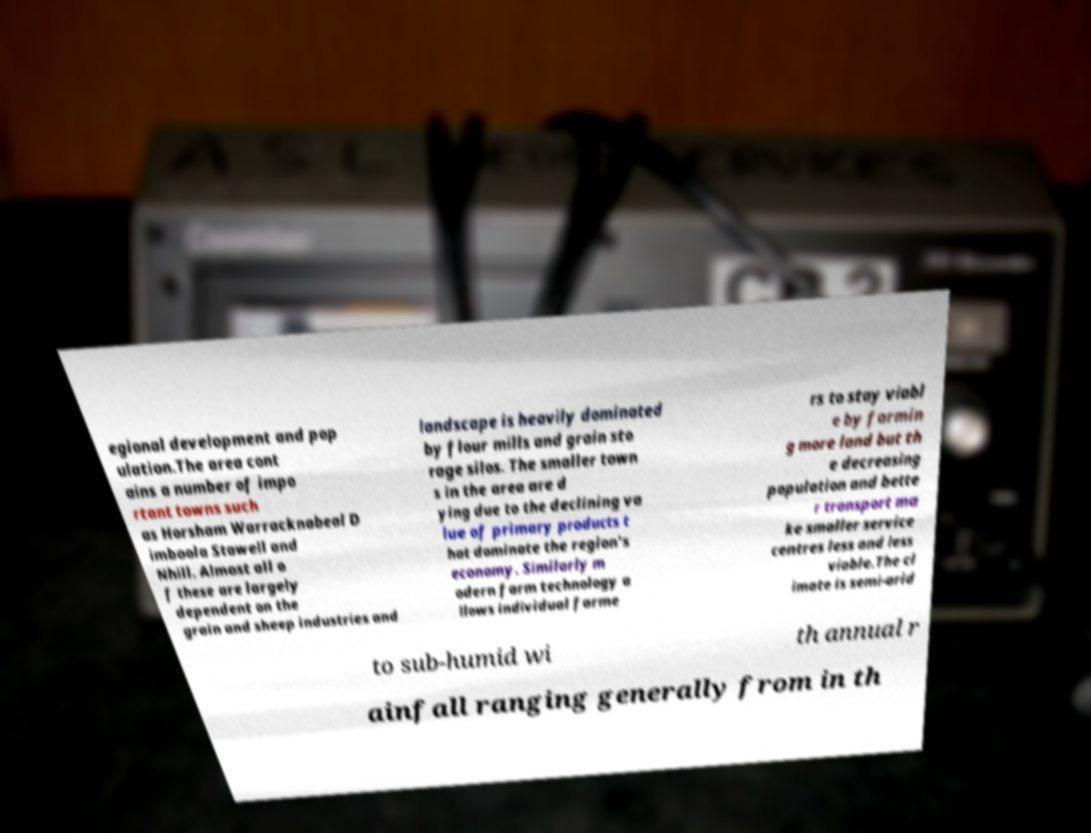Can you read and provide the text displayed in the image?This photo seems to have some interesting text. Can you extract and type it out for me? egional development and pop ulation.The area cont ains a number of impo rtant towns such as Horsham Warracknabeal D imboola Stawell and Nhill. Almost all o f these are largely dependent on the grain and sheep industries and landscape is heavily dominated by flour mills and grain sto rage silos. The smaller town s in the area are d ying due to the declining va lue of primary products t hat dominate the region's economy. Similarly m odern farm technology a llows individual farme rs to stay viabl e by farmin g more land but th e decreasing population and bette r transport ma ke smaller service centres less and less viable.The cl imate is semi-arid to sub-humid wi th annual r ainfall ranging generally from in th 